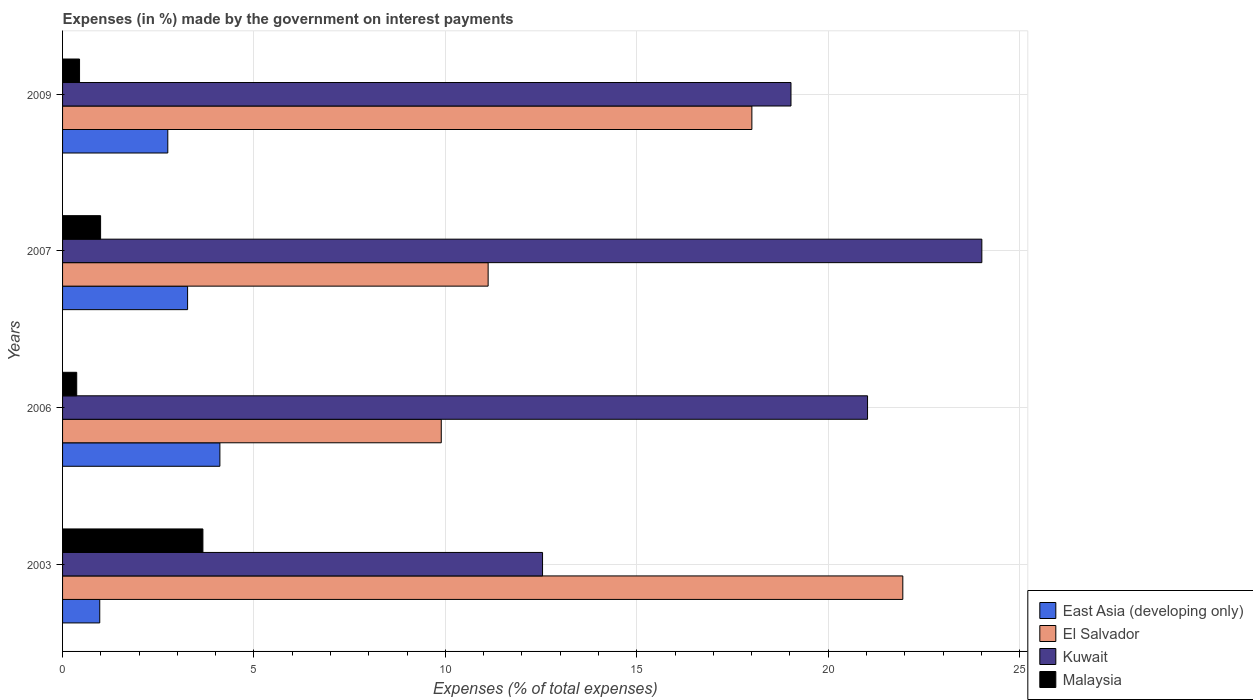How many different coloured bars are there?
Your answer should be compact. 4. Are the number of bars per tick equal to the number of legend labels?
Give a very brief answer. Yes. How many bars are there on the 1st tick from the top?
Ensure brevity in your answer.  4. How many bars are there on the 3rd tick from the bottom?
Make the answer very short. 4. What is the label of the 4th group of bars from the top?
Your response must be concise. 2003. In how many cases, is the number of bars for a given year not equal to the number of legend labels?
Provide a short and direct response. 0. What is the percentage of expenses made by the government on interest payments in Malaysia in 2003?
Make the answer very short. 3.67. Across all years, what is the maximum percentage of expenses made by the government on interest payments in Kuwait?
Offer a very short reply. 24.01. Across all years, what is the minimum percentage of expenses made by the government on interest payments in East Asia (developing only)?
Your answer should be very brief. 0.97. In which year was the percentage of expenses made by the government on interest payments in Kuwait minimum?
Make the answer very short. 2003. What is the total percentage of expenses made by the government on interest payments in East Asia (developing only) in the graph?
Keep it short and to the point. 11.1. What is the difference between the percentage of expenses made by the government on interest payments in El Salvador in 2003 and that in 2009?
Your answer should be very brief. 3.94. What is the difference between the percentage of expenses made by the government on interest payments in East Asia (developing only) in 2009 and the percentage of expenses made by the government on interest payments in Kuwait in 2007?
Give a very brief answer. -21.27. What is the average percentage of expenses made by the government on interest payments in East Asia (developing only) per year?
Offer a very short reply. 2.77. In the year 2007, what is the difference between the percentage of expenses made by the government on interest payments in Malaysia and percentage of expenses made by the government on interest payments in El Salvador?
Make the answer very short. -10.12. What is the ratio of the percentage of expenses made by the government on interest payments in East Asia (developing only) in 2007 to that in 2009?
Ensure brevity in your answer.  1.19. Is the difference between the percentage of expenses made by the government on interest payments in Malaysia in 2007 and 2009 greater than the difference between the percentage of expenses made by the government on interest payments in El Salvador in 2007 and 2009?
Your answer should be compact. Yes. What is the difference between the highest and the second highest percentage of expenses made by the government on interest payments in Kuwait?
Your answer should be very brief. 2.99. What is the difference between the highest and the lowest percentage of expenses made by the government on interest payments in Malaysia?
Your answer should be compact. 3.3. In how many years, is the percentage of expenses made by the government on interest payments in East Asia (developing only) greater than the average percentage of expenses made by the government on interest payments in East Asia (developing only) taken over all years?
Your answer should be very brief. 2. What does the 2nd bar from the top in 2009 represents?
Make the answer very short. Kuwait. What does the 2nd bar from the bottom in 2003 represents?
Offer a very short reply. El Salvador. Is it the case that in every year, the sum of the percentage of expenses made by the government on interest payments in Malaysia and percentage of expenses made by the government on interest payments in Kuwait is greater than the percentage of expenses made by the government on interest payments in East Asia (developing only)?
Your answer should be very brief. Yes. How many bars are there?
Offer a very short reply. 16. Are all the bars in the graph horizontal?
Your answer should be very brief. Yes. How many years are there in the graph?
Your answer should be compact. 4. What is the difference between two consecutive major ticks on the X-axis?
Ensure brevity in your answer.  5. Are the values on the major ticks of X-axis written in scientific E-notation?
Make the answer very short. No. Does the graph contain any zero values?
Offer a very short reply. No. How many legend labels are there?
Your response must be concise. 4. How are the legend labels stacked?
Provide a succinct answer. Vertical. What is the title of the graph?
Ensure brevity in your answer.  Expenses (in %) made by the government on interest payments. What is the label or title of the X-axis?
Give a very brief answer. Expenses (% of total expenses). What is the Expenses (% of total expenses) of East Asia (developing only) in 2003?
Ensure brevity in your answer.  0.97. What is the Expenses (% of total expenses) in El Salvador in 2003?
Your response must be concise. 21.95. What is the Expenses (% of total expenses) of Kuwait in 2003?
Your response must be concise. 12.54. What is the Expenses (% of total expenses) in Malaysia in 2003?
Offer a terse response. 3.67. What is the Expenses (% of total expenses) of East Asia (developing only) in 2006?
Your answer should be compact. 4.11. What is the Expenses (% of total expenses) of El Salvador in 2006?
Give a very brief answer. 9.89. What is the Expenses (% of total expenses) in Kuwait in 2006?
Offer a terse response. 21.03. What is the Expenses (% of total expenses) of Malaysia in 2006?
Your answer should be compact. 0.37. What is the Expenses (% of total expenses) of East Asia (developing only) in 2007?
Offer a terse response. 3.27. What is the Expenses (% of total expenses) of El Salvador in 2007?
Give a very brief answer. 11.12. What is the Expenses (% of total expenses) in Kuwait in 2007?
Give a very brief answer. 24.01. What is the Expenses (% of total expenses) of Malaysia in 2007?
Your answer should be very brief. 0.99. What is the Expenses (% of total expenses) in East Asia (developing only) in 2009?
Ensure brevity in your answer.  2.75. What is the Expenses (% of total expenses) in El Salvador in 2009?
Give a very brief answer. 18.01. What is the Expenses (% of total expenses) in Kuwait in 2009?
Make the answer very short. 19.03. What is the Expenses (% of total expenses) in Malaysia in 2009?
Your response must be concise. 0.44. Across all years, what is the maximum Expenses (% of total expenses) in East Asia (developing only)?
Provide a short and direct response. 4.11. Across all years, what is the maximum Expenses (% of total expenses) of El Salvador?
Give a very brief answer. 21.95. Across all years, what is the maximum Expenses (% of total expenses) of Kuwait?
Provide a succinct answer. 24.01. Across all years, what is the maximum Expenses (% of total expenses) of Malaysia?
Offer a terse response. 3.67. Across all years, what is the minimum Expenses (% of total expenses) of East Asia (developing only)?
Offer a terse response. 0.97. Across all years, what is the minimum Expenses (% of total expenses) of El Salvador?
Your answer should be compact. 9.89. Across all years, what is the minimum Expenses (% of total expenses) in Kuwait?
Make the answer very short. 12.54. Across all years, what is the minimum Expenses (% of total expenses) in Malaysia?
Your answer should be compact. 0.37. What is the total Expenses (% of total expenses) in East Asia (developing only) in the graph?
Ensure brevity in your answer.  11.1. What is the total Expenses (% of total expenses) of El Salvador in the graph?
Offer a very short reply. 60.97. What is the total Expenses (% of total expenses) of Kuwait in the graph?
Provide a short and direct response. 76.61. What is the total Expenses (% of total expenses) of Malaysia in the graph?
Ensure brevity in your answer.  5.47. What is the difference between the Expenses (% of total expenses) of East Asia (developing only) in 2003 and that in 2006?
Ensure brevity in your answer.  -3.14. What is the difference between the Expenses (% of total expenses) of El Salvador in 2003 and that in 2006?
Your response must be concise. 12.06. What is the difference between the Expenses (% of total expenses) of Kuwait in 2003 and that in 2006?
Your answer should be compact. -8.49. What is the difference between the Expenses (% of total expenses) in Malaysia in 2003 and that in 2006?
Your response must be concise. 3.3. What is the difference between the Expenses (% of total expenses) of East Asia (developing only) in 2003 and that in 2007?
Offer a terse response. -2.29. What is the difference between the Expenses (% of total expenses) of El Salvador in 2003 and that in 2007?
Provide a succinct answer. 10.83. What is the difference between the Expenses (% of total expenses) of Kuwait in 2003 and that in 2007?
Provide a short and direct response. -11.48. What is the difference between the Expenses (% of total expenses) in Malaysia in 2003 and that in 2007?
Ensure brevity in your answer.  2.67. What is the difference between the Expenses (% of total expenses) of East Asia (developing only) in 2003 and that in 2009?
Ensure brevity in your answer.  -1.78. What is the difference between the Expenses (% of total expenses) of El Salvador in 2003 and that in 2009?
Ensure brevity in your answer.  3.94. What is the difference between the Expenses (% of total expenses) of Kuwait in 2003 and that in 2009?
Provide a short and direct response. -6.49. What is the difference between the Expenses (% of total expenses) in Malaysia in 2003 and that in 2009?
Offer a very short reply. 3.22. What is the difference between the Expenses (% of total expenses) of East Asia (developing only) in 2006 and that in 2007?
Offer a very short reply. 0.84. What is the difference between the Expenses (% of total expenses) in El Salvador in 2006 and that in 2007?
Make the answer very short. -1.22. What is the difference between the Expenses (% of total expenses) in Kuwait in 2006 and that in 2007?
Your answer should be very brief. -2.99. What is the difference between the Expenses (% of total expenses) of Malaysia in 2006 and that in 2007?
Keep it short and to the point. -0.62. What is the difference between the Expenses (% of total expenses) of East Asia (developing only) in 2006 and that in 2009?
Make the answer very short. 1.36. What is the difference between the Expenses (% of total expenses) of El Salvador in 2006 and that in 2009?
Offer a terse response. -8.11. What is the difference between the Expenses (% of total expenses) of Kuwait in 2006 and that in 2009?
Your answer should be very brief. 2. What is the difference between the Expenses (% of total expenses) in Malaysia in 2006 and that in 2009?
Offer a terse response. -0.07. What is the difference between the Expenses (% of total expenses) in East Asia (developing only) in 2007 and that in 2009?
Your answer should be compact. 0.52. What is the difference between the Expenses (% of total expenses) in El Salvador in 2007 and that in 2009?
Your answer should be compact. -6.89. What is the difference between the Expenses (% of total expenses) of Kuwait in 2007 and that in 2009?
Give a very brief answer. 4.99. What is the difference between the Expenses (% of total expenses) in Malaysia in 2007 and that in 2009?
Offer a terse response. 0.55. What is the difference between the Expenses (% of total expenses) in East Asia (developing only) in 2003 and the Expenses (% of total expenses) in El Salvador in 2006?
Ensure brevity in your answer.  -8.92. What is the difference between the Expenses (% of total expenses) in East Asia (developing only) in 2003 and the Expenses (% of total expenses) in Kuwait in 2006?
Provide a short and direct response. -20.06. What is the difference between the Expenses (% of total expenses) in East Asia (developing only) in 2003 and the Expenses (% of total expenses) in Malaysia in 2006?
Give a very brief answer. 0.6. What is the difference between the Expenses (% of total expenses) of El Salvador in 2003 and the Expenses (% of total expenses) of Kuwait in 2006?
Give a very brief answer. 0.92. What is the difference between the Expenses (% of total expenses) in El Salvador in 2003 and the Expenses (% of total expenses) in Malaysia in 2006?
Offer a very short reply. 21.58. What is the difference between the Expenses (% of total expenses) of Kuwait in 2003 and the Expenses (% of total expenses) of Malaysia in 2006?
Your answer should be very brief. 12.17. What is the difference between the Expenses (% of total expenses) of East Asia (developing only) in 2003 and the Expenses (% of total expenses) of El Salvador in 2007?
Make the answer very short. -10.15. What is the difference between the Expenses (% of total expenses) of East Asia (developing only) in 2003 and the Expenses (% of total expenses) of Kuwait in 2007?
Your answer should be compact. -23.04. What is the difference between the Expenses (% of total expenses) in East Asia (developing only) in 2003 and the Expenses (% of total expenses) in Malaysia in 2007?
Provide a short and direct response. -0.02. What is the difference between the Expenses (% of total expenses) of El Salvador in 2003 and the Expenses (% of total expenses) of Kuwait in 2007?
Provide a short and direct response. -2.06. What is the difference between the Expenses (% of total expenses) in El Salvador in 2003 and the Expenses (% of total expenses) in Malaysia in 2007?
Offer a terse response. 20.96. What is the difference between the Expenses (% of total expenses) in Kuwait in 2003 and the Expenses (% of total expenses) in Malaysia in 2007?
Make the answer very short. 11.55. What is the difference between the Expenses (% of total expenses) in East Asia (developing only) in 2003 and the Expenses (% of total expenses) in El Salvador in 2009?
Ensure brevity in your answer.  -17.03. What is the difference between the Expenses (% of total expenses) in East Asia (developing only) in 2003 and the Expenses (% of total expenses) in Kuwait in 2009?
Ensure brevity in your answer.  -18.06. What is the difference between the Expenses (% of total expenses) of East Asia (developing only) in 2003 and the Expenses (% of total expenses) of Malaysia in 2009?
Give a very brief answer. 0.53. What is the difference between the Expenses (% of total expenses) of El Salvador in 2003 and the Expenses (% of total expenses) of Kuwait in 2009?
Make the answer very short. 2.92. What is the difference between the Expenses (% of total expenses) of El Salvador in 2003 and the Expenses (% of total expenses) of Malaysia in 2009?
Provide a succinct answer. 21.51. What is the difference between the Expenses (% of total expenses) in Kuwait in 2003 and the Expenses (% of total expenses) in Malaysia in 2009?
Offer a very short reply. 12.1. What is the difference between the Expenses (% of total expenses) of East Asia (developing only) in 2006 and the Expenses (% of total expenses) of El Salvador in 2007?
Keep it short and to the point. -7.01. What is the difference between the Expenses (% of total expenses) in East Asia (developing only) in 2006 and the Expenses (% of total expenses) in Kuwait in 2007?
Your response must be concise. -19.9. What is the difference between the Expenses (% of total expenses) of East Asia (developing only) in 2006 and the Expenses (% of total expenses) of Malaysia in 2007?
Your response must be concise. 3.12. What is the difference between the Expenses (% of total expenses) in El Salvador in 2006 and the Expenses (% of total expenses) in Kuwait in 2007?
Keep it short and to the point. -14.12. What is the difference between the Expenses (% of total expenses) of El Salvador in 2006 and the Expenses (% of total expenses) of Malaysia in 2007?
Provide a short and direct response. 8.9. What is the difference between the Expenses (% of total expenses) of Kuwait in 2006 and the Expenses (% of total expenses) of Malaysia in 2007?
Offer a very short reply. 20.04. What is the difference between the Expenses (% of total expenses) in East Asia (developing only) in 2006 and the Expenses (% of total expenses) in El Salvador in 2009?
Offer a terse response. -13.9. What is the difference between the Expenses (% of total expenses) of East Asia (developing only) in 2006 and the Expenses (% of total expenses) of Kuwait in 2009?
Provide a succinct answer. -14.92. What is the difference between the Expenses (% of total expenses) in East Asia (developing only) in 2006 and the Expenses (% of total expenses) in Malaysia in 2009?
Keep it short and to the point. 3.67. What is the difference between the Expenses (% of total expenses) in El Salvador in 2006 and the Expenses (% of total expenses) in Kuwait in 2009?
Provide a short and direct response. -9.14. What is the difference between the Expenses (% of total expenses) of El Salvador in 2006 and the Expenses (% of total expenses) of Malaysia in 2009?
Offer a terse response. 9.45. What is the difference between the Expenses (% of total expenses) in Kuwait in 2006 and the Expenses (% of total expenses) in Malaysia in 2009?
Keep it short and to the point. 20.58. What is the difference between the Expenses (% of total expenses) of East Asia (developing only) in 2007 and the Expenses (% of total expenses) of El Salvador in 2009?
Provide a succinct answer. -14.74. What is the difference between the Expenses (% of total expenses) of East Asia (developing only) in 2007 and the Expenses (% of total expenses) of Kuwait in 2009?
Ensure brevity in your answer.  -15.76. What is the difference between the Expenses (% of total expenses) in East Asia (developing only) in 2007 and the Expenses (% of total expenses) in Malaysia in 2009?
Give a very brief answer. 2.82. What is the difference between the Expenses (% of total expenses) in El Salvador in 2007 and the Expenses (% of total expenses) in Kuwait in 2009?
Your response must be concise. -7.91. What is the difference between the Expenses (% of total expenses) in El Salvador in 2007 and the Expenses (% of total expenses) in Malaysia in 2009?
Your answer should be very brief. 10.67. What is the difference between the Expenses (% of total expenses) of Kuwait in 2007 and the Expenses (% of total expenses) of Malaysia in 2009?
Make the answer very short. 23.57. What is the average Expenses (% of total expenses) of East Asia (developing only) per year?
Provide a short and direct response. 2.77. What is the average Expenses (% of total expenses) in El Salvador per year?
Offer a terse response. 15.24. What is the average Expenses (% of total expenses) of Kuwait per year?
Make the answer very short. 19.15. What is the average Expenses (% of total expenses) of Malaysia per year?
Offer a terse response. 1.37. In the year 2003, what is the difference between the Expenses (% of total expenses) in East Asia (developing only) and Expenses (% of total expenses) in El Salvador?
Ensure brevity in your answer.  -20.98. In the year 2003, what is the difference between the Expenses (% of total expenses) of East Asia (developing only) and Expenses (% of total expenses) of Kuwait?
Your response must be concise. -11.57. In the year 2003, what is the difference between the Expenses (% of total expenses) of East Asia (developing only) and Expenses (% of total expenses) of Malaysia?
Ensure brevity in your answer.  -2.69. In the year 2003, what is the difference between the Expenses (% of total expenses) of El Salvador and Expenses (% of total expenses) of Kuwait?
Make the answer very short. 9.41. In the year 2003, what is the difference between the Expenses (% of total expenses) in El Salvador and Expenses (% of total expenses) in Malaysia?
Make the answer very short. 18.28. In the year 2003, what is the difference between the Expenses (% of total expenses) in Kuwait and Expenses (% of total expenses) in Malaysia?
Keep it short and to the point. 8.87. In the year 2006, what is the difference between the Expenses (% of total expenses) in East Asia (developing only) and Expenses (% of total expenses) in El Salvador?
Your answer should be compact. -5.78. In the year 2006, what is the difference between the Expenses (% of total expenses) in East Asia (developing only) and Expenses (% of total expenses) in Kuwait?
Offer a very short reply. -16.92. In the year 2006, what is the difference between the Expenses (% of total expenses) of East Asia (developing only) and Expenses (% of total expenses) of Malaysia?
Make the answer very short. 3.74. In the year 2006, what is the difference between the Expenses (% of total expenses) in El Salvador and Expenses (% of total expenses) in Kuwait?
Ensure brevity in your answer.  -11.14. In the year 2006, what is the difference between the Expenses (% of total expenses) of El Salvador and Expenses (% of total expenses) of Malaysia?
Make the answer very short. 9.52. In the year 2006, what is the difference between the Expenses (% of total expenses) of Kuwait and Expenses (% of total expenses) of Malaysia?
Offer a very short reply. 20.66. In the year 2007, what is the difference between the Expenses (% of total expenses) in East Asia (developing only) and Expenses (% of total expenses) in El Salvador?
Give a very brief answer. -7.85. In the year 2007, what is the difference between the Expenses (% of total expenses) in East Asia (developing only) and Expenses (% of total expenses) in Kuwait?
Make the answer very short. -20.75. In the year 2007, what is the difference between the Expenses (% of total expenses) in East Asia (developing only) and Expenses (% of total expenses) in Malaysia?
Your answer should be compact. 2.27. In the year 2007, what is the difference between the Expenses (% of total expenses) of El Salvador and Expenses (% of total expenses) of Kuwait?
Give a very brief answer. -12.9. In the year 2007, what is the difference between the Expenses (% of total expenses) in El Salvador and Expenses (% of total expenses) in Malaysia?
Provide a succinct answer. 10.12. In the year 2007, what is the difference between the Expenses (% of total expenses) of Kuwait and Expenses (% of total expenses) of Malaysia?
Offer a terse response. 23.02. In the year 2009, what is the difference between the Expenses (% of total expenses) of East Asia (developing only) and Expenses (% of total expenses) of El Salvador?
Offer a terse response. -15.26. In the year 2009, what is the difference between the Expenses (% of total expenses) of East Asia (developing only) and Expenses (% of total expenses) of Kuwait?
Your response must be concise. -16.28. In the year 2009, what is the difference between the Expenses (% of total expenses) in East Asia (developing only) and Expenses (% of total expenses) in Malaysia?
Ensure brevity in your answer.  2.31. In the year 2009, what is the difference between the Expenses (% of total expenses) in El Salvador and Expenses (% of total expenses) in Kuwait?
Keep it short and to the point. -1.02. In the year 2009, what is the difference between the Expenses (% of total expenses) of El Salvador and Expenses (% of total expenses) of Malaysia?
Give a very brief answer. 17.56. In the year 2009, what is the difference between the Expenses (% of total expenses) of Kuwait and Expenses (% of total expenses) of Malaysia?
Make the answer very short. 18.58. What is the ratio of the Expenses (% of total expenses) in East Asia (developing only) in 2003 to that in 2006?
Give a very brief answer. 0.24. What is the ratio of the Expenses (% of total expenses) of El Salvador in 2003 to that in 2006?
Make the answer very short. 2.22. What is the ratio of the Expenses (% of total expenses) in Kuwait in 2003 to that in 2006?
Provide a succinct answer. 0.6. What is the ratio of the Expenses (% of total expenses) in Malaysia in 2003 to that in 2006?
Make the answer very short. 9.92. What is the ratio of the Expenses (% of total expenses) in East Asia (developing only) in 2003 to that in 2007?
Ensure brevity in your answer.  0.3. What is the ratio of the Expenses (% of total expenses) in El Salvador in 2003 to that in 2007?
Your response must be concise. 1.97. What is the ratio of the Expenses (% of total expenses) of Kuwait in 2003 to that in 2007?
Your answer should be compact. 0.52. What is the ratio of the Expenses (% of total expenses) of Malaysia in 2003 to that in 2007?
Provide a succinct answer. 3.69. What is the ratio of the Expenses (% of total expenses) in East Asia (developing only) in 2003 to that in 2009?
Make the answer very short. 0.35. What is the ratio of the Expenses (% of total expenses) in El Salvador in 2003 to that in 2009?
Provide a short and direct response. 1.22. What is the ratio of the Expenses (% of total expenses) in Kuwait in 2003 to that in 2009?
Offer a terse response. 0.66. What is the ratio of the Expenses (% of total expenses) in Malaysia in 2003 to that in 2009?
Your answer should be compact. 8.27. What is the ratio of the Expenses (% of total expenses) of East Asia (developing only) in 2006 to that in 2007?
Your answer should be compact. 1.26. What is the ratio of the Expenses (% of total expenses) of El Salvador in 2006 to that in 2007?
Your answer should be compact. 0.89. What is the ratio of the Expenses (% of total expenses) in Kuwait in 2006 to that in 2007?
Make the answer very short. 0.88. What is the ratio of the Expenses (% of total expenses) of Malaysia in 2006 to that in 2007?
Give a very brief answer. 0.37. What is the ratio of the Expenses (% of total expenses) in East Asia (developing only) in 2006 to that in 2009?
Make the answer very short. 1.5. What is the ratio of the Expenses (% of total expenses) of El Salvador in 2006 to that in 2009?
Ensure brevity in your answer.  0.55. What is the ratio of the Expenses (% of total expenses) of Kuwait in 2006 to that in 2009?
Provide a short and direct response. 1.11. What is the ratio of the Expenses (% of total expenses) of Malaysia in 2006 to that in 2009?
Provide a short and direct response. 0.83. What is the ratio of the Expenses (% of total expenses) in East Asia (developing only) in 2007 to that in 2009?
Give a very brief answer. 1.19. What is the ratio of the Expenses (% of total expenses) in El Salvador in 2007 to that in 2009?
Make the answer very short. 0.62. What is the ratio of the Expenses (% of total expenses) in Kuwait in 2007 to that in 2009?
Keep it short and to the point. 1.26. What is the ratio of the Expenses (% of total expenses) in Malaysia in 2007 to that in 2009?
Offer a very short reply. 2.24. What is the difference between the highest and the second highest Expenses (% of total expenses) in East Asia (developing only)?
Provide a short and direct response. 0.84. What is the difference between the highest and the second highest Expenses (% of total expenses) of El Salvador?
Make the answer very short. 3.94. What is the difference between the highest and the second highest Expenses (% of total expenses) in Kuwait?
Your response must be concise. 2.99. What is the difference between the highest and the second highest Expenses (% of total expenses) in Malaysia?
Make the answer very short. 2.67. What is the difference between the highest and the lowest Expenses (% of total expenses) in East Asia (developing only)?
Your answer should be very brief. 3.14. What is the difference between the highest and the lowest Expenses (% of total expenses) of El Salvador?
Your answer should be very brief. 12.06. What is the difference between the highest and the lowest Expenses (% of total expenses) of Kuwait?
Keep it short and to the point. 11.48. What is the difference between the highest and the lowest Expenses (% of total expenses) of Malaysia?
Your answer should be compact. 3.3. 